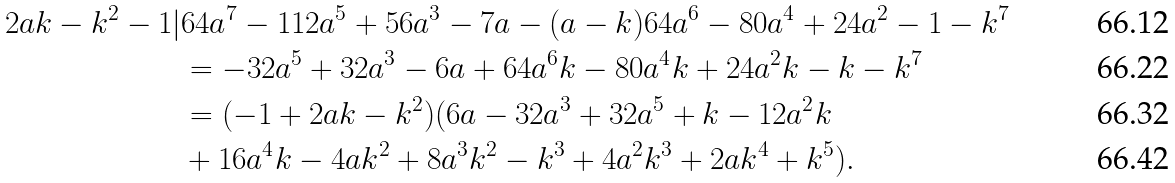<formula> <loc_0><loc_0><loc_500><loc_500>2 a k - k ^ { 2 } - 1 | & 6 4 a ^ { 7 } - 1 1 2 a ^ { 5 } + 5 6 a ^ { 3 } - 7 a - ( a - k ) 6 4 a ^ { 6 } - 8 0 a ^ { 4 } + 2 4 a ^ { 2 } - 1 - k ^ { 7 } \\ & = - 3 2 a ^ { 5 } + 3 2 a ^ { 3 } - 6 a + 6 4 a ^ { 6 } k - 8 0 a ^ { 4 } k + 2 4 a ^ { 2 } k - k - k ^ { 7 } \\ & = ( - 1 + 2 a k - k ^ { 2 } ) ( 6 a - 3 2 a ^ { 3 } + 3 2 a ^ { 5 } + k - 1 2 a ^ { 2 } k \\ & + 1 6 a ^ { 4 } k - 4 a k ^ { 2 } + 8 a ^ { 3 } k ^ { 2 } - k ^ { 3 } + 4 a ^ { 2 } k ^ { 3 } + 2 a k ^ { 4 } + k ^ { 5 } ) .</formula> 